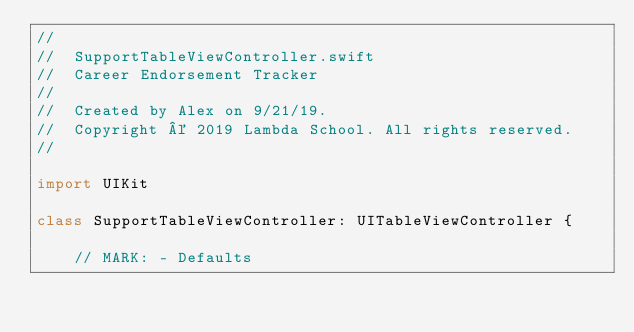<code> <loc_0><loc_0><loc_500><loc_500><_Swift_>//
//  SupportTableViewController.swift
//  Career Endorsement Tracker
//
//  Created by Alex on 9/21/19.
//  Copyright © 2019 Lambda School. All rights reserved.
//

import UIKit

class SupportTableViewController: UITableViewController {
    
    // MARK: - Defaults</code> 